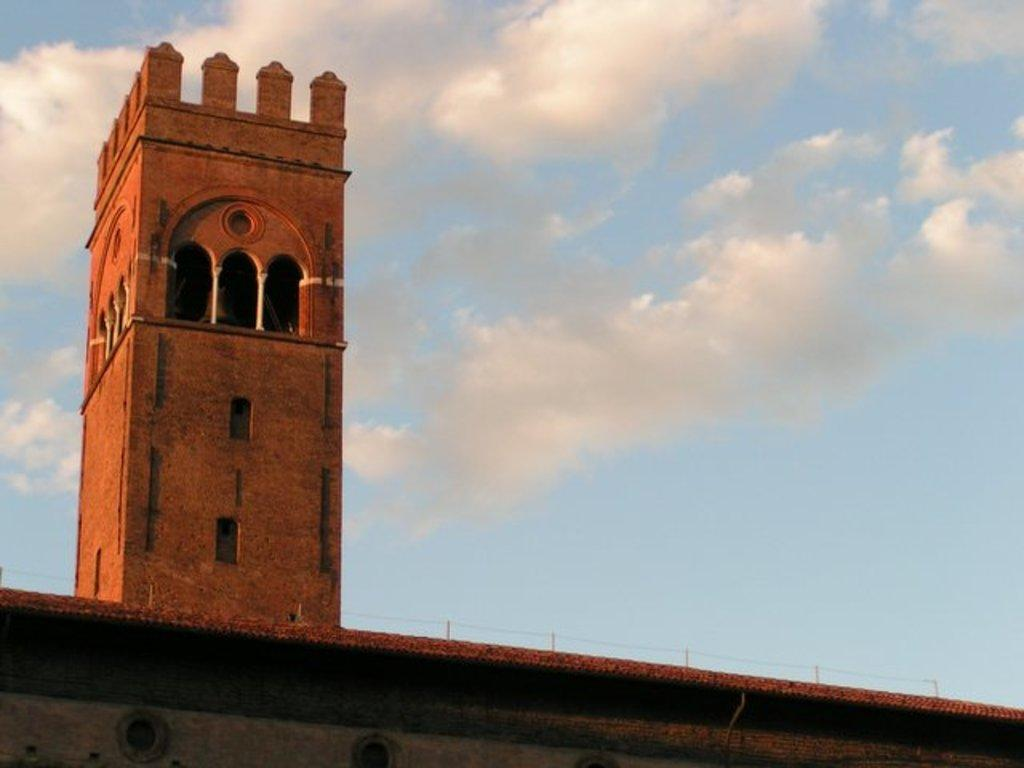What structure is located at the bottom of the image? There is a building at the bottom of the image. What can be seen in the sky in the image? There are clouds in the sky. What part of the natural environment is visible in the image? The sky is visible in the image. What type of cloth is draped over the deer in the image? There is no deer present in the image, and therefore no cloth draped over it. 